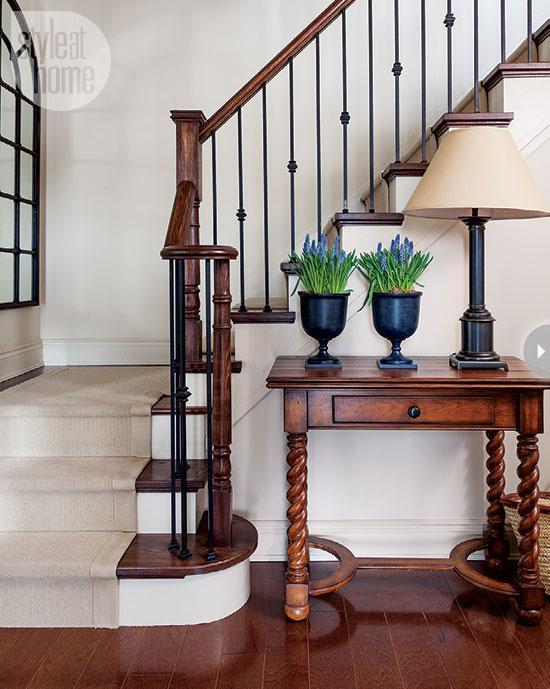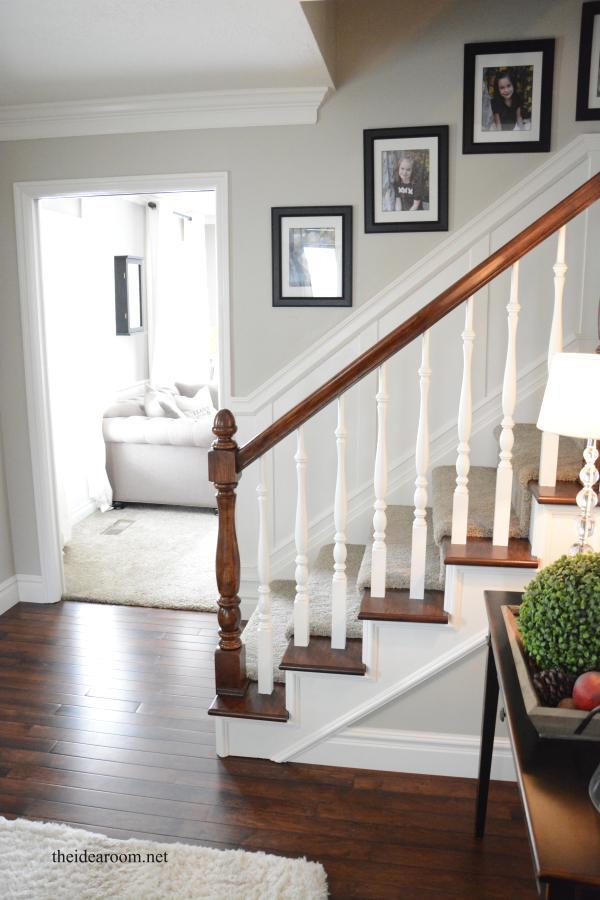The first image is the image on the left, the second image is the image on the right. Considering the images on both sides, is "One stairway changes direction." valid? Answer yes or no. Yes. 